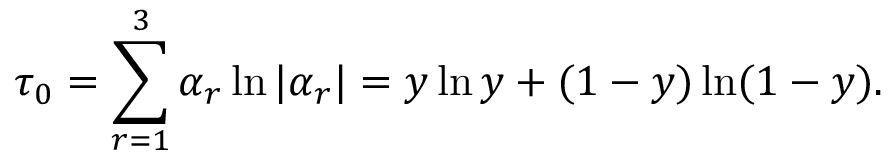Convert formula to latex. <formula><loc_0><loc_0><loc_500><loc_500>\tau _ { 0 } = \sum _ { r = 1 } ^ { 3 } \alpha _ { r } \ln | \alpha _ { r } | = y \ln y + ( 1 - y ) \ln ( 1 - y ) .</formula> 